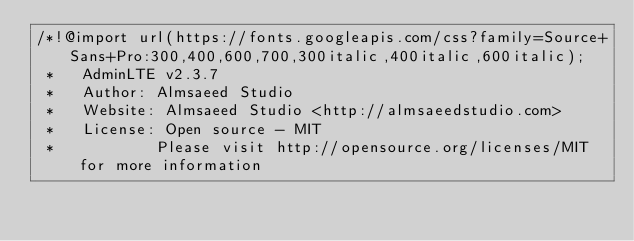<code> <loc_0><loc_0><loc_500><loc_500><_CSS_>/*!@import url(https://fonts.googleapis.com/css?family=Source+Sans+Pro:300,400,600,700,300italic,400italic,600italic);
 *   AdminLTE v2.3.7
 *   Author: Almsaeed Studio
 *	 Website: Almsaeed Studio <http://almsaeedstudio.com>
 *   License: Open source - MIT
 *           Please visit http://opensource.org/licenses/MIT for more information</code> 